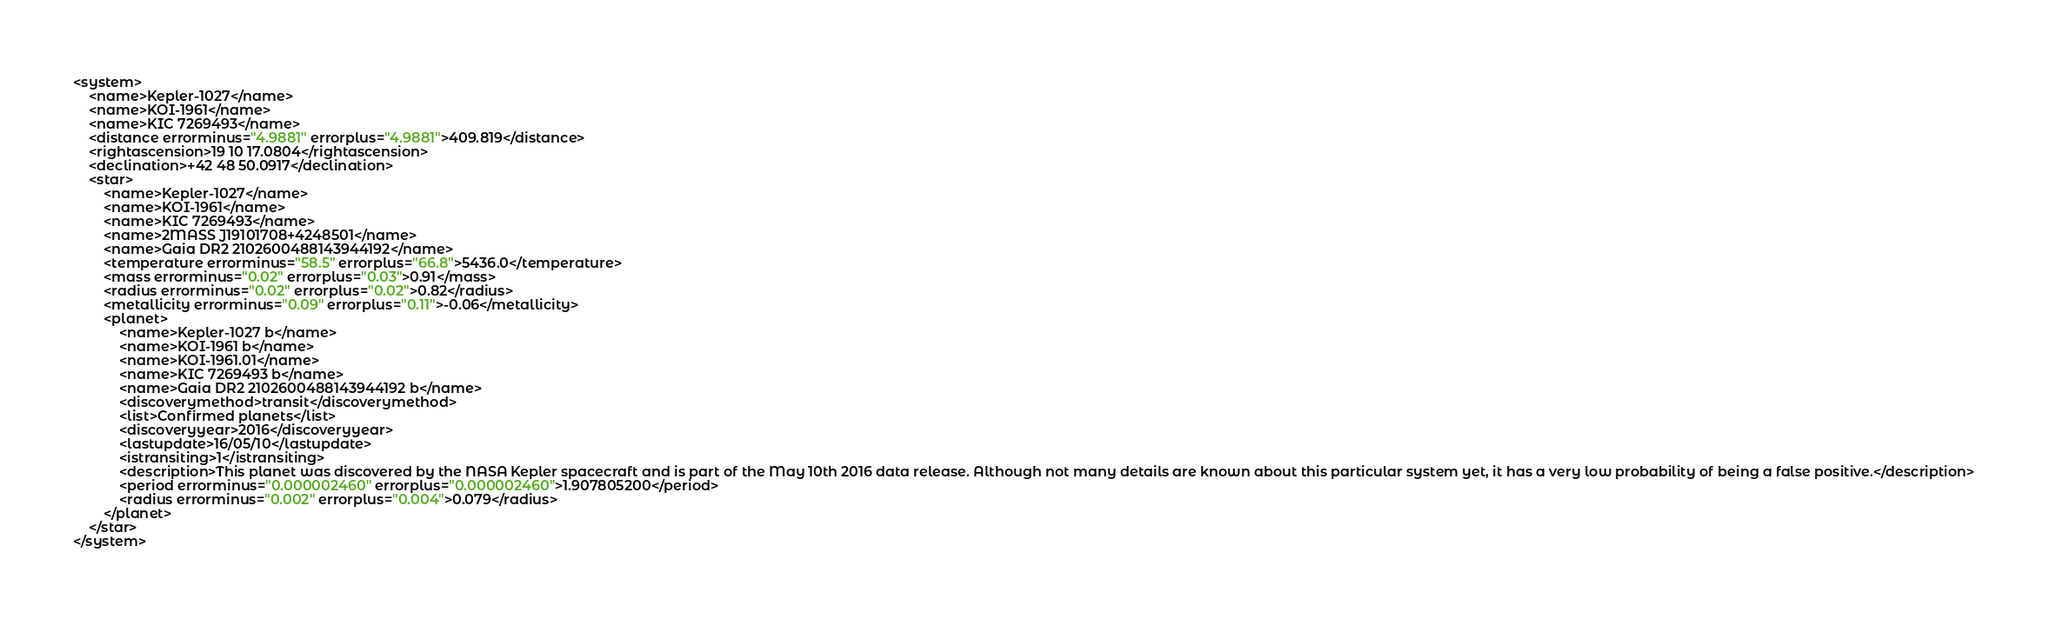Convert code to text. <code><loc_0><loc_0><loc_500><loc_500><_XML_><system>
	<name>Kepler-1027</name>
	<name>KOI-1961</name>
	<name>KIC 7269493</name>
	<distance errorminus="4.9881" errorplus="4.9881">409.819</distance>
	<rightascension>19 10 17.0804</rightascension>
	<declination>+42 48 50.0917</declination>
	<star>
		<name>Kepler-1027</name>
		<name>KOI-1961</name>
		<name>KIC 7269493</name>
		<name>2MASS J19101708+4248501</name>
		<name>Gaia DR2 2102600488143944192</name>
		<temperature errorminus="58.5" errorplus="66.8">5436.0</temperature>
		<mass errorminus="0.02" errorplus="0.03">0.91</mass>
		<radius errorminus="0.02" errorplus="0.02">0.82</radius>
		<metallicity errorminus="0.09" errorplus="0.11">-0.06</metallicity>
		<planet>
			<name>Kepler-1027 b</name>
			<name>KOI-1961 b</name>
			<name>KOI-1961.01</name>
			<name>KIC 7269493 b</name>
			<name>Gaia DR2 2102600488143944192 b</name>
			<discoverymethod>transit</discoverymethod>
			<list>Confirmed planets</list>
			<discoveryyear>2016</discoveryyear>
			<lastupdate>16/05/10</lastupdate>
			<istransiting>1</istransiting>
			<description>This planet was discovered by the NASA Kepler spacecraft and is part of the May 10th 2016 data release. Although not many details are known about this particular system yet, it has a very low probability of being a false positive.</description>
			<period errorminus="0.000002460" errorplus="0.000002460">1.907805200</period>
			<radius errorminus="0.002" errorplus="0.004">0.079</radius>
		</planet>
	</star>
</system>
</code> 